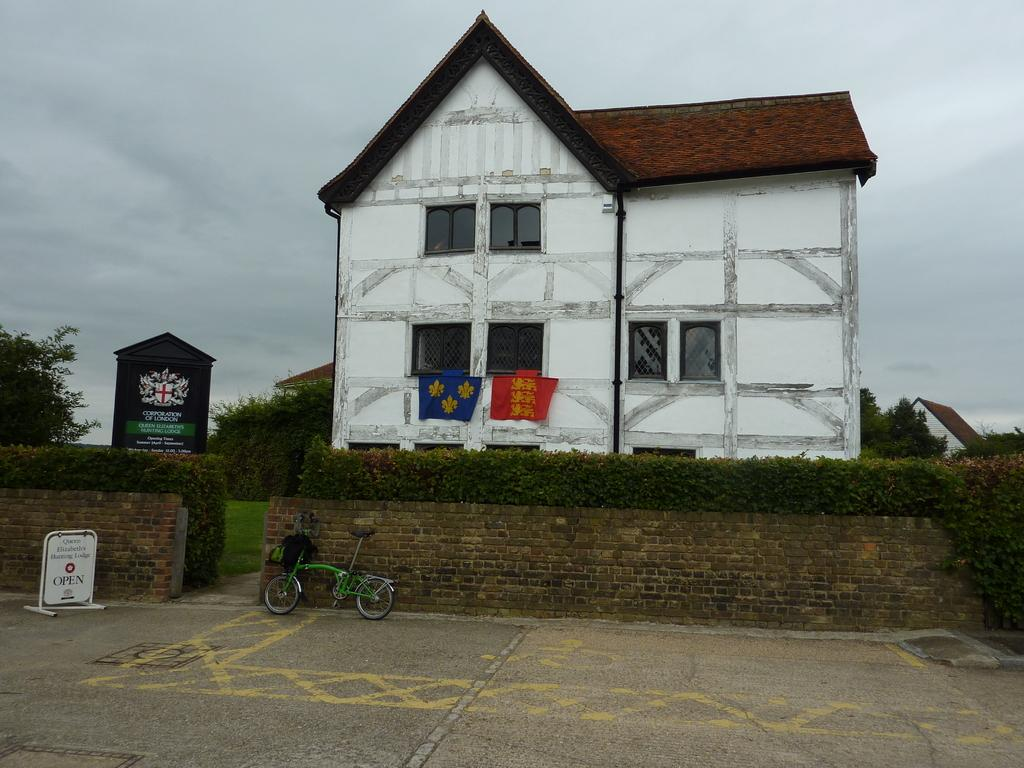What type of structures can be seen in the image? There are buildings in the image. What is the material of the wall visible in the image? There is a brick wall in the image. What type of vegetation is present in the image? There are trees in the image. What can be seen hanging or placed in the image? There are clothes visible in the image. What mode of transportation is parked in the image? There is a bicycle parked in the image. What is the weather like in the image? The sky is cloudy in the image. What type of hair can be seen on the stove in the image? There is no stove or hair present in the image. What kind of toy is visible on the tree in the image? There is no toy present in the image; only buildings, a brick wall, trees, clothes, a bicycle, and a cloudy sky are visible. 